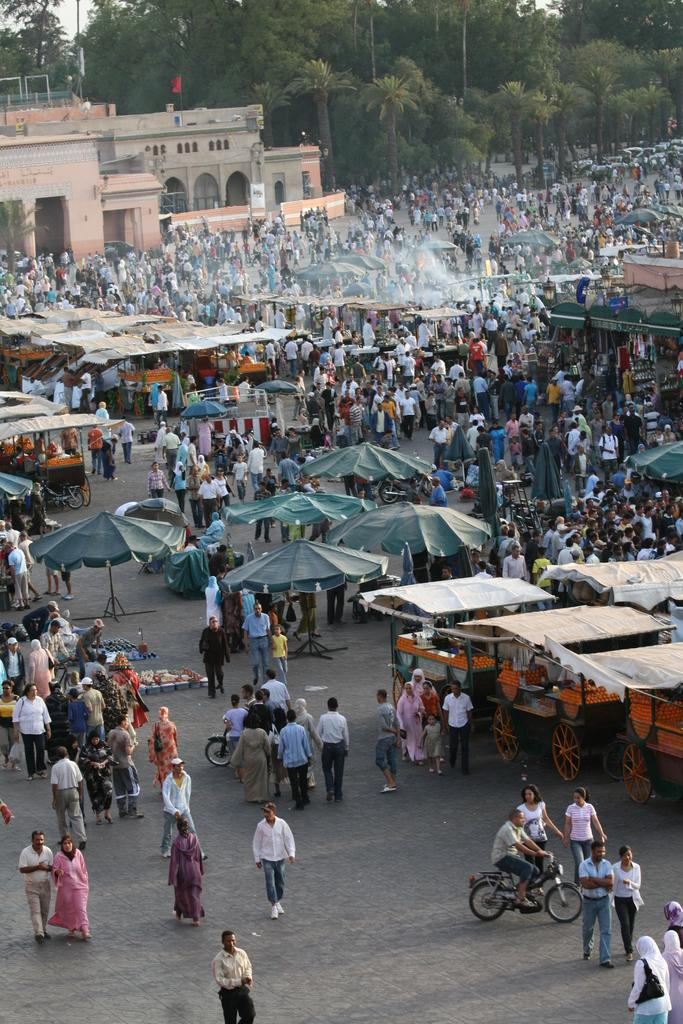What are the people in the image doing? There are people standing, walking, and riding motorcycles in the image. What objects are being used to protect against the weather in the image? There are umbrellas visible in the image. What type of vehicles can be seen in the image? There are carts in the image. What structures are present in the background of the image? There are buildings in the image. What type of vegetation is present in the image? There are trees in the image. What type of pies are being sold by the people riding motorcycles in the image? There is no mention of pies or any food items being sold in the image. 